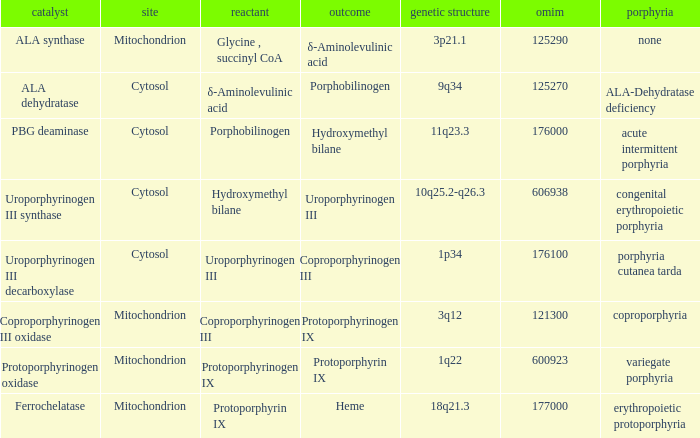Which substrate has an OMIM of 176000? Porphobilinogen. 